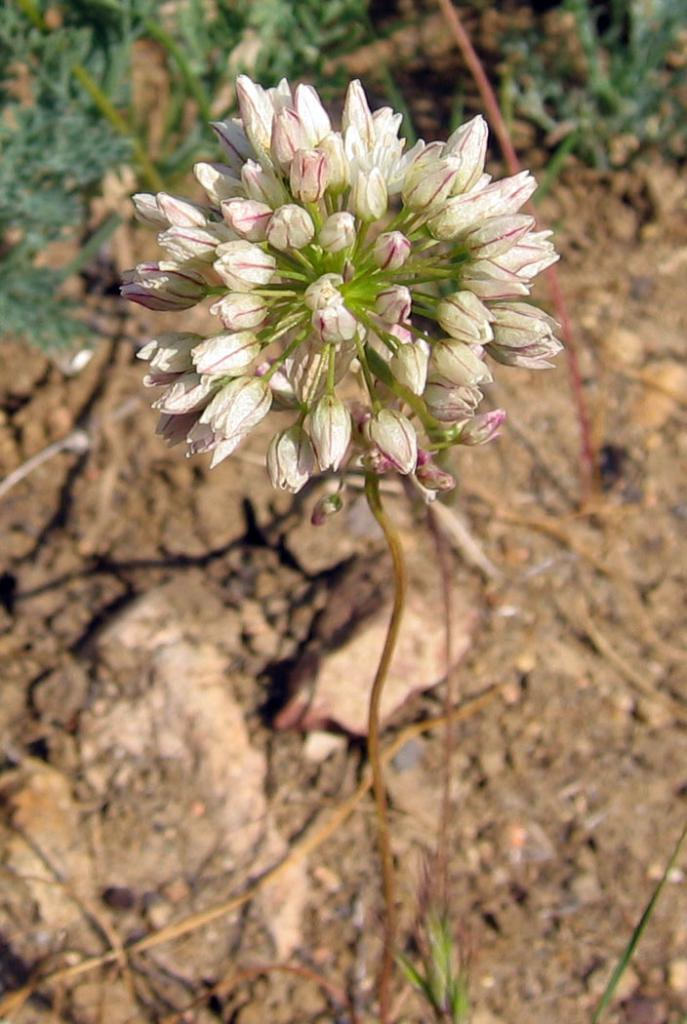What is the main subject of the image? There is a flower in the image. What can be seen in the background of the image? There are trees in the background of the image. What is the flower's primary use in the image? The image does not provide information about the flower's use, as it is a still image and not an action shot. 